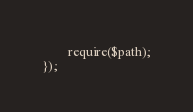<code> <loc_0><loc_0><loc_500><loc_500><_PHP_>		require($path);
});
</code> 